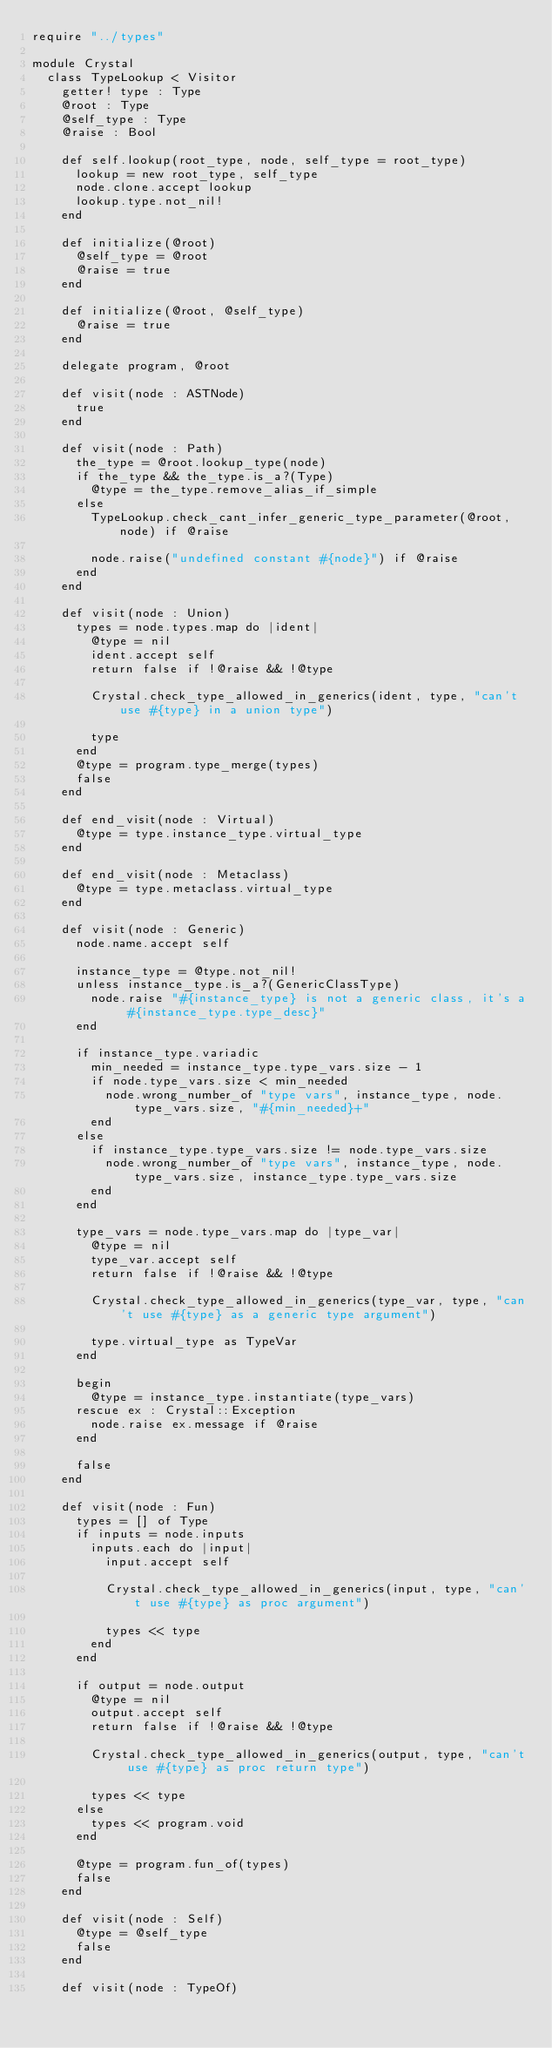Convert code to text. <code><loc_0><loc_0><loc_500><loc_500><_Crystal_>require "../types"

module Crystal
  class TypeLookup < Visitor
    getter! type : Type
    @root : Type
    @self_type : Type
    @raise : Bool

    def self.lookup(root_type, node, self_type = root_type)
      lookup = new root_type, self_type
      node.clone.accept lookup
      lookup.type.not_nil!
    end

    def initialize(@root)
      @self_type = @root
      @raise = true
    end

    def initialize(@root, @self_type)
      @raise = true
    end

    delegate program, @root

    def visit(node : ASTNode)
      true
    end

    def visit(node : Path)
      the_type = @root.lookup_type(node)
      if the_type && the_type.is_a?(Type)
        @type = the_type.remove_alias_if_simple
      else
        TypeLookup.check_cant_infer_generic_type_parameter(@root, node) if @raise

        node.raise("undefined constant #{node}") if @raise
      end
    end

    def visit(node : Union)
      types = node.types.map do |ident|
        @type = nil
        ident.accept self
        return false if !@raise && !@type

        Crystal.check_type_allowed_in_generics(ident, type, "can't use #{type} in a union type")

        type
      end
      @type = program.type_merge(types)
      false
    end

    def end_visit(node : Virtual)
      @type = type.instance_type.virtual_type
    end

    def end_visit(node : Metaclass)
      @type = type.metaclass.virtual_type
    end

    def visit(node : Generic)
      node.name.accept self

      instance_type = @type.not_nil!
      unless instance_type.is_a?(GenericClassType)
        node.raise "#{instance_type} is not a generic class, it's a #{instance_type.type_desc}"
      end

      if instance_type.variadic
        min_needed = instance_type.type_vars.size - 1
        if node.type_vars.size < min_needed
          node.wrong_number_of "type vars", instance_type, node.type_vars.size, "#{min_needed}+"
        end
      else
        if instance_type.type_vars.size != node.type_vars.size
          node.wrong_number_of "type vars", instance_type, node.type_vars.size, instance_type.type_vars.size
        end
      end

      type_vars = node.type_vars.map do |type_var|
        @type = nil
        type_var.accept self
        return false if !@raise && !@type

        Crystal.check_type_allowed_in_generics(type_var, type, "can't use #{type} as a generic type argument")

        type.virtual_type as TypeVar
      end

      begin
        @type = instance_type.instantiate(type_vars)
      rescue ex : Crystal::Exception
        node.raise ex.message if @raise
      end

      false
    end

    def visit(node : Fun)
      types = [] of Type
      if inputs = node.inputs
        inputs.each do |input|
          input.accept self

          Crystal.check_type_allowed_in_generics(input, type, "can't use #{type} as proc argument")

          types << type
        end
      end

      if output = node.output
        @type = nil
        output.accept self
        return false if !@raise && !@type

        Crystal.check_type_allowed_in_generics(output, type, "can't use #{type} as proc return type")

        types << type
      else
        types << program.void
      end

      @type = program.fun_of(types)
      false
    end

    def visit(node : Self)
      @type = @self_type
      false
    end

    def visit(node : TypeOf)</code> 